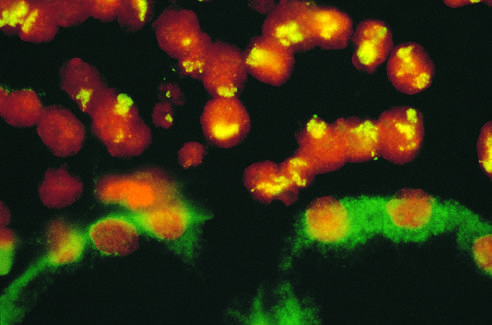what does this correspond to in the form of homogeneously staining regions?
Answer the question using a single word or phrase. Amplified n-myc 